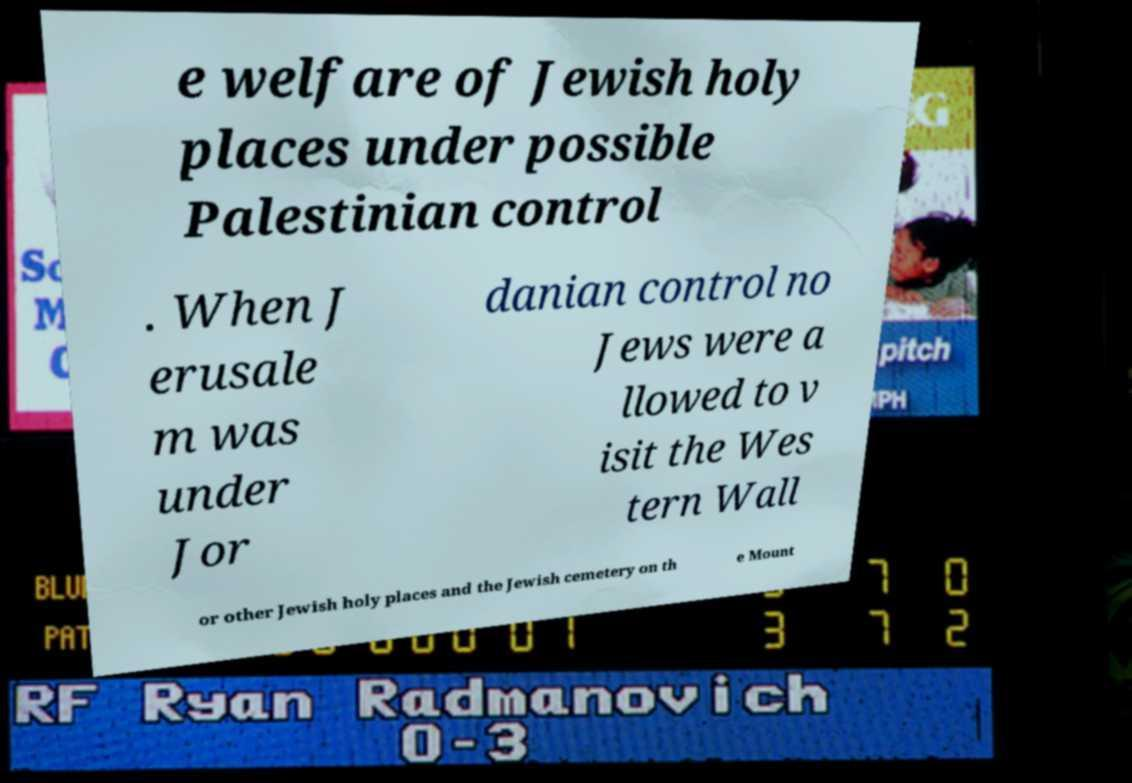Could you extract and type out the text from this image? e welfare of Jewish holy places under possible Palestinian control . When J erusale m was under Jor danian control no Jews were a llowed to v isit the Wes tern Wall or other Jewish holy places and the Jewish cemetery on th e Mount 